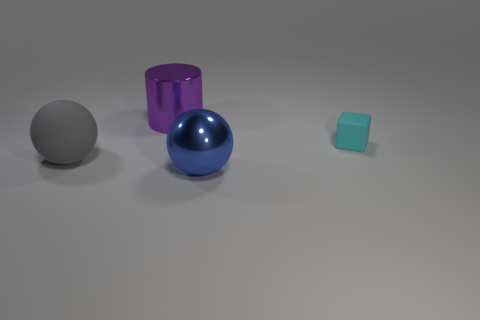Add 4 red shiny cubes. How many objects exist? 8 Subtract all cubes. How many objects are left? 3 Add 1 big gray metal things. How many big gray metal things exist? 1 Subtract 0 brown cylinders. How many objects are left? 4 Subtract all gray rubber balls. Subtract all small red metal things. How many objects are left? 3 Add 2 rubber spheres. How many rubber spheres are left? 3 